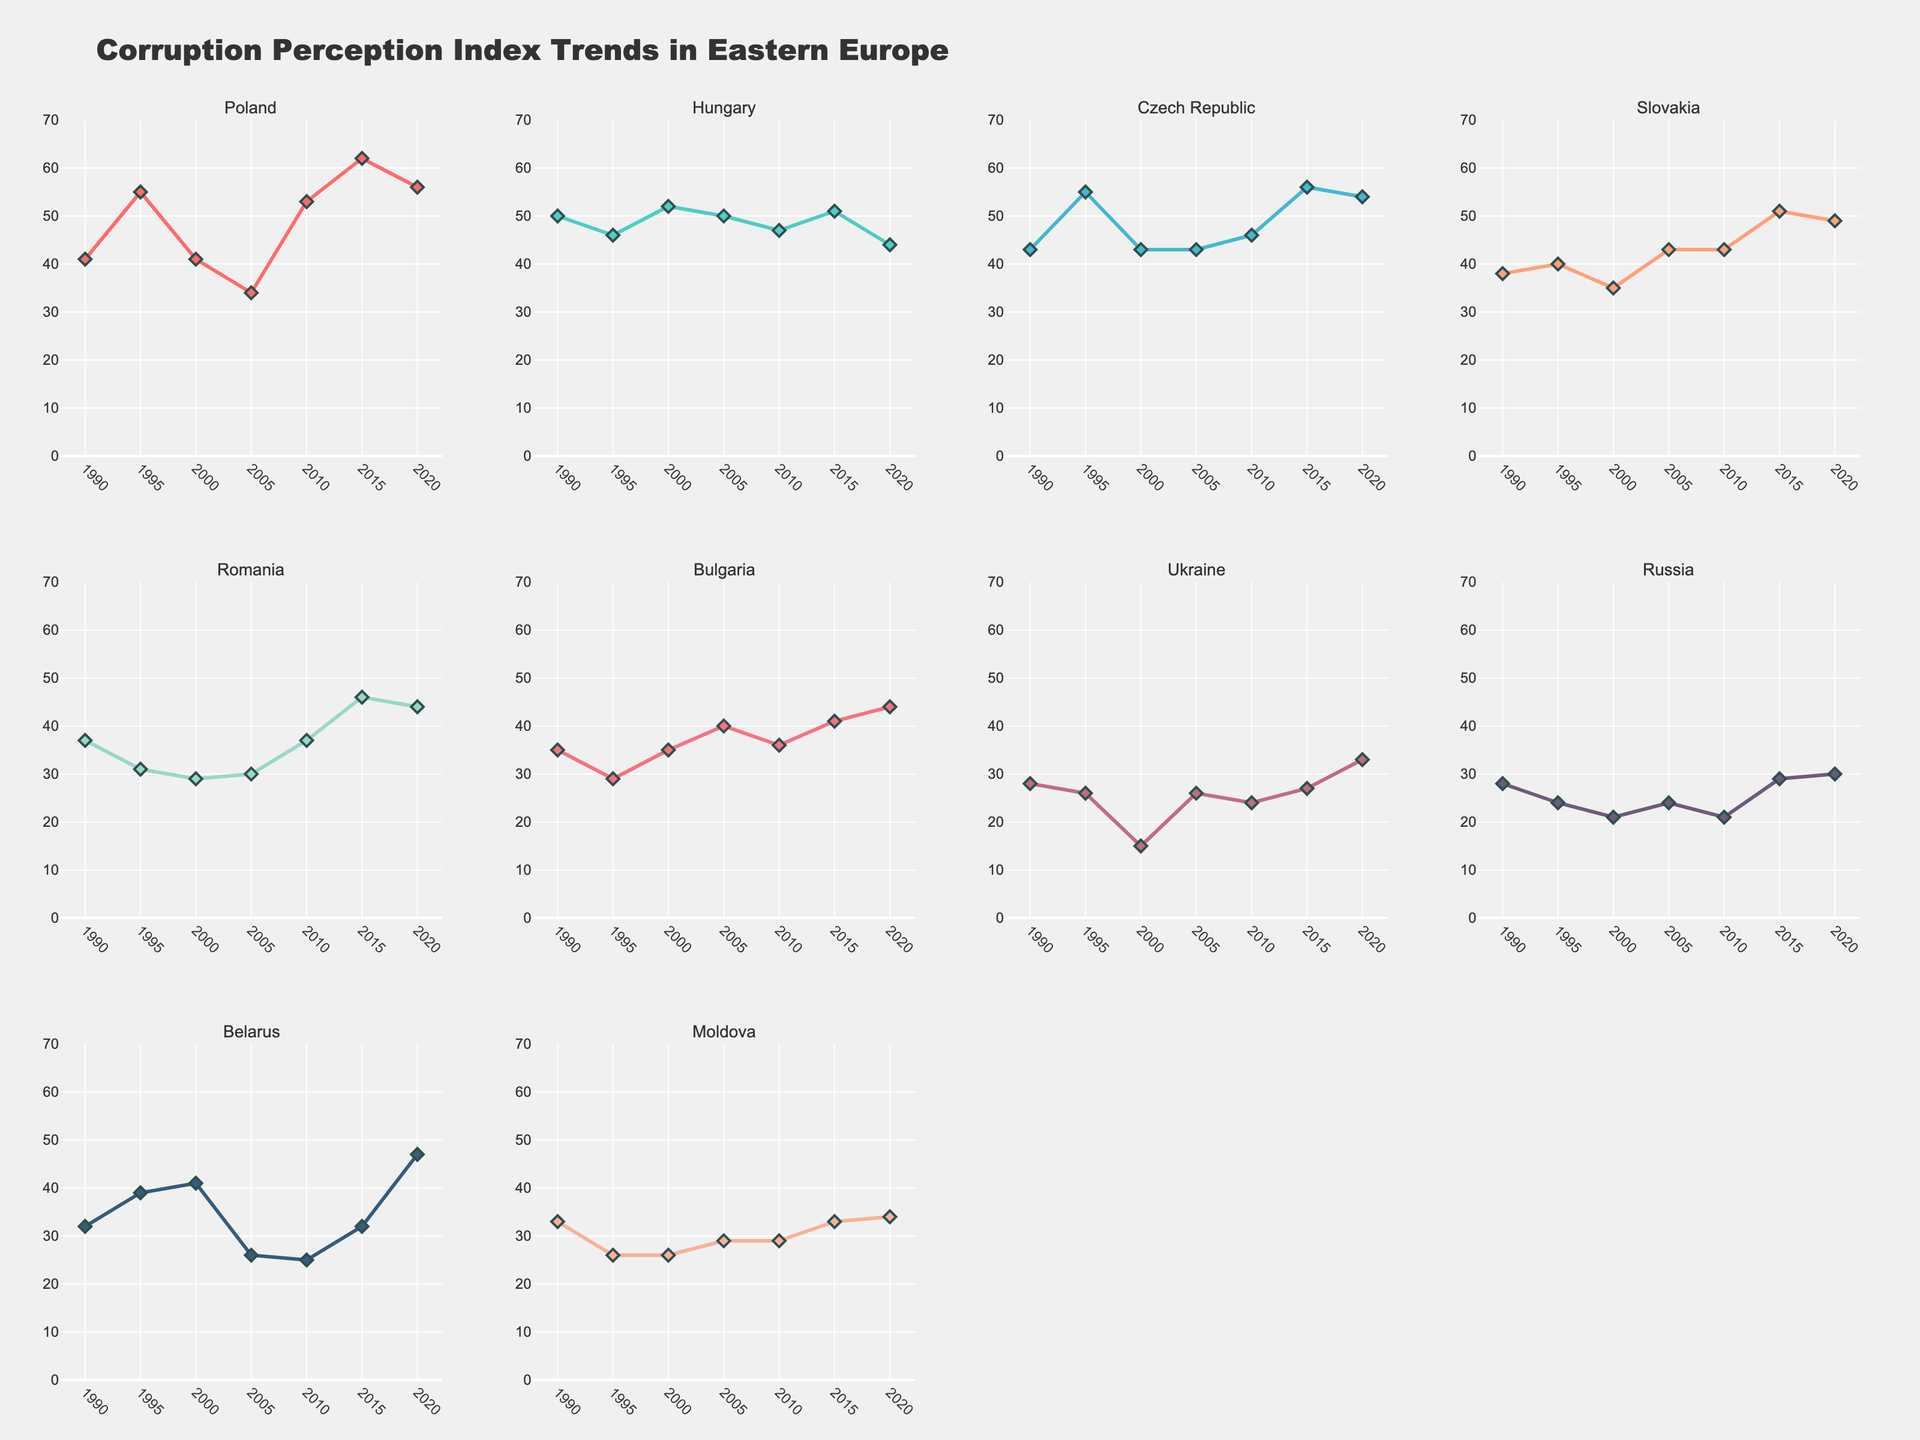What is the title of the figure? The title is displayed at the top of the figure and usually summarizes the main content. Here, the title reads, "Corruption Perception Index Trends in Eastern Europe".
Answer: Corruption Perception Index Trends in Eastern Europe How many countries' data are represented in the subplots? Each subplot represents one country, and there are 10 subplots in total. The title of each subplot corresponds to a different country.
Answer: 10 Which country shows the highest Corruption Perception Index in 2020? By observing the endpoints of the lines for the year 2020 in each subplot, Poland has the highest index value, which is 56.
Answer: Poland Which countries show an increase in their Corruption Perception Index from 1990 to 2020? By comparing the starting and ending points in each subplot, the countries with an increase from 1990 to 2020 are Poland, Czech Republic, Bulgaria, Ukraine, and Belarus.
Answer: Poland, Czech Republic, Bulgaria, Ukraine, Belarus What is the average Corruption Perception Index of Hungary over the years displayed? Sum the values from Hungary's subplot (50, 46, 52, 50, 47, 51, 44) and divide by the number of data points: (50 + 46 + 52 + 50 + 47 + 51 + 44) / 7 = 48.57.
Answer: 48.57 Which country has shown the most significant decrease in their Corruption Perception Index? By observing the changes in index values between 1990 and 2020, Russia's index dropped from 28 in 1990 to 30 in 2020, representing a nearly stable index, while other countries show overall increases or minimal decreases. Hence, Moldova's trends show more significant instability with minor increments.
Answer: Moldova Between Poland and Hungary, which country had the higher Corruption Perception Index in 2010? Looking at the 2010 data points in the subplots for Poland and Hungary, Poland had an index of 53, whereas Hungary's was 47.
Answer: Poland Which country's Corruption Perception Index had the most fluctuations over the years? By visually inspecting the subplots for variations in lines, Romania’s subplot shows significant fluctuations, ranging from 31 to 46 over the span.
Answer: Romania What is the common y-axis range used for all subplots in the figure? Observing the y-axis of every subplot, the range is consistently set from 0 to 70.
Answer: 0 to 70 Between Belarus and Moldova, which country’s Corruption Perception Index was worse in 2005, and what were the values? Referencing the 2005 data points in their respective subplots, Belarus had an index of 26, and Moldova had a value of 29. Lower values indicate worse perception; thus, Belarus had a worse index.
Answer: Belarus, 26 and 29 